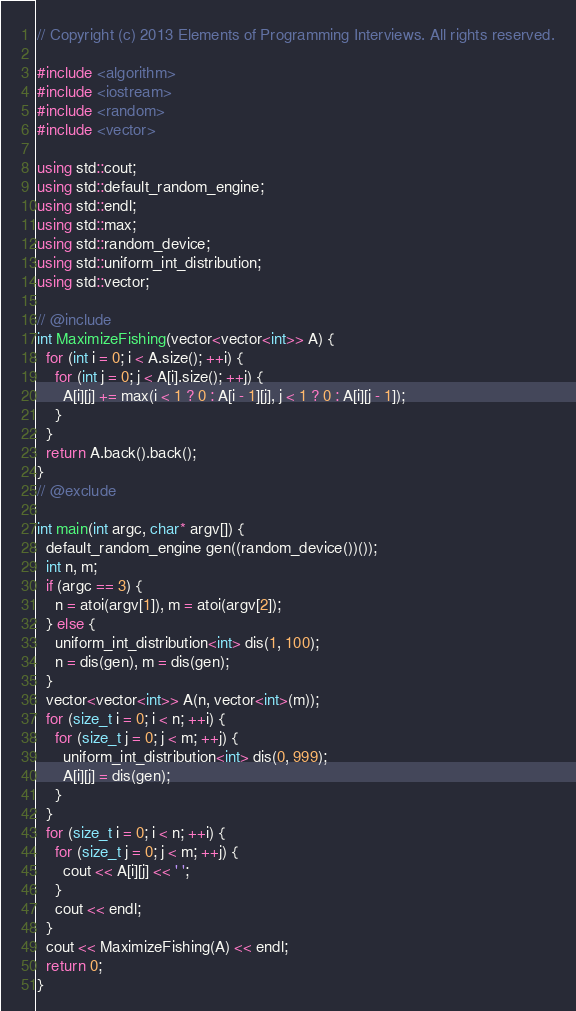<code> <loc_0><loc_0><loc_500><loc_500><_C++_>// Copyright (c) 2013 Elements of Programming Interviews. All rights reserved.

#include <algorithm>
#include <iostream>
#include <random>
#include <vector>

using std::cout;
using std::default_random_engine;
using std::endl;
using std::max;
using std::random_device;
using std::uniform_int_distribution;
using std::vector;

// @include
int MaximizeFishing(vector<vector<int>> A) {
  for (int i = 0; i < A.size(); ++i) {
    for (int j = 0; j < A[i].size(); ++j) {
      A[i][j] += max(i < 1 ? 0 : A[i - 1][j], j < 1 ? 0 : A[i][j - 1]);
    }
  }
  return A.back().back();
}
// @exclude

int main(int argc, char* argv[]) {
  default_random_engine gen((random_device())());
  int n, m;
  if (argc == 3) {
    n = atoi(argv[1]), m = atoi(argv[2]);
  } else {
    uniform_int_distribution<int> dis(1, 100);
    n = dis(gen), m = dis(gen);
  }
  vector<vector<int>> A(n, vector<int>(m));
  for (size_t i = 0; i < n; ++i) {
    for (size_t j = 0; j < m; ++j) {
      uniform_int_distribution<int> dis(0, 999);
      A[i][j] = dis(gen);
    }
  }
  for (size_t i = 0; i < n; ++i) {
    for (size_t j = 0; j < m; ++j) {
      cout << A[i][j] << ' ';
    }
    cout << endl;
  }
  cout << MaximizeFishing(A) << endl;
  return 0;
}
</code> 